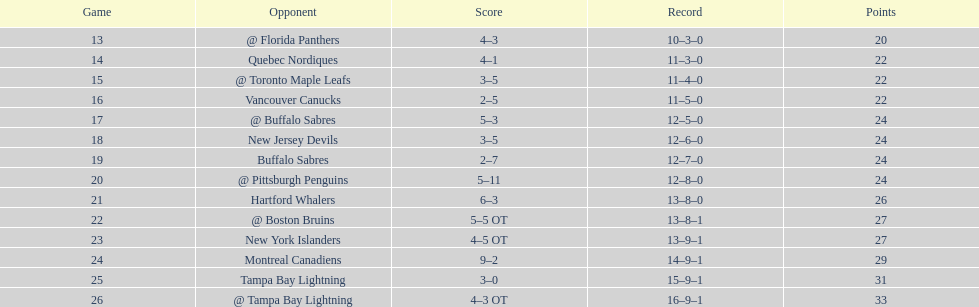What other team had the closest amount of wins? New York Islanders. 